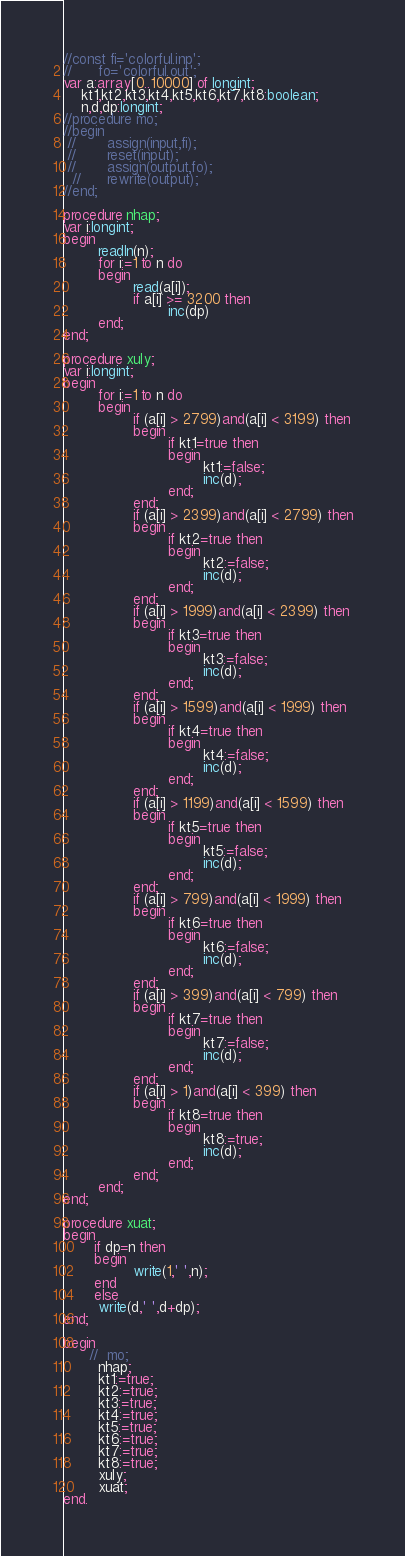<code> <loc_0><loc_0><loc_500><loc_500><_Pascal_>//const fi='colorful.inp';
//      fo='colorful.out';
var a:array[0..10000] of longint;
    kt1,kt2,kt3,kt4,kt5,kt6,kt7,kt8:boolean;
    n,d,dp:longint;
//procedure mo;
//begin
 //       assign(input,fi);
 //       reset(input);
 //       assign(output,fo);
  //      rewrite(output);
//end;

procedure nhap;
var i:longint;
begin
        readln(n);
        for i:=1 to n do
        begin
                read(a[i]);
                if a[i] >= 3200 then
                        inc(dp)
        end;
end;

procedure xuly;
var i:longint;
begin
        for i:=1 to n do
        begin
                if (a[i] > 2799)and(a[i] < 3199) then
                begin
                        if kt1=true then
                        begin
                                kt1:=false;
                                inc(d);
                        end;
                end;
                if (a[i] > 2399)and(a[i] < 2799) then
                begin
                        if kt2=true then
                        begin
                                kt2:=false;
                                inc(d);
                        end;
                end;
                if (a[i] > 1999)and(a[i] < 2399) then
                begin
                        if kt3=true then
                        begin
                                kt3:=false;
                                inc(d);
                        end;
                end;
                if (a[i] > 1599)and(a[i] < 1999) then
                begin
                        if kt4=true then
                        begin
                                kt4:=false;
                                inc(d);
                        end;
                end;
                if (a[i] > 1199)and(a[i] < 1599) then
                begin
                        if kt5=true then
                        begin
                                kt5:=false;
                                inc(d);
                        end;
                end;
                if (a[i] > 799)and(a[i] < 1999) then
                begin
                        if kt6=true then
                        begin
                                kt6:=false;
                                inc(d);
                        end;
                end;
                if (a[i] > 399)and(a[i] < 799) then
                begin
                        if kt7=true then
                        begin
                                kt7:=false;
                                inc(d);
                        end;
                end;
                if (a[i] > 1)and(a[i] < 399) then
                begin
                        if kt8=true then
                        begin
                                kt8:=true;
                                inc(d);
                        end;
                end;
        end;
end;

procedure xuat;
begin
       if dp=n then
       begin
                write(1,' ',n);
       end
       else
        write(d,' ',d+dp);
end;

begin
      //  mo;
        nhap;
        kt1:=true;
        kt2:=true;
        kt3:=true;
        kt4:=true;
        kt5:=true;
        kt6:=true;
        kt7:=true;
        kt8:=true;
        xuly;
        xuat;
end.
</code> 